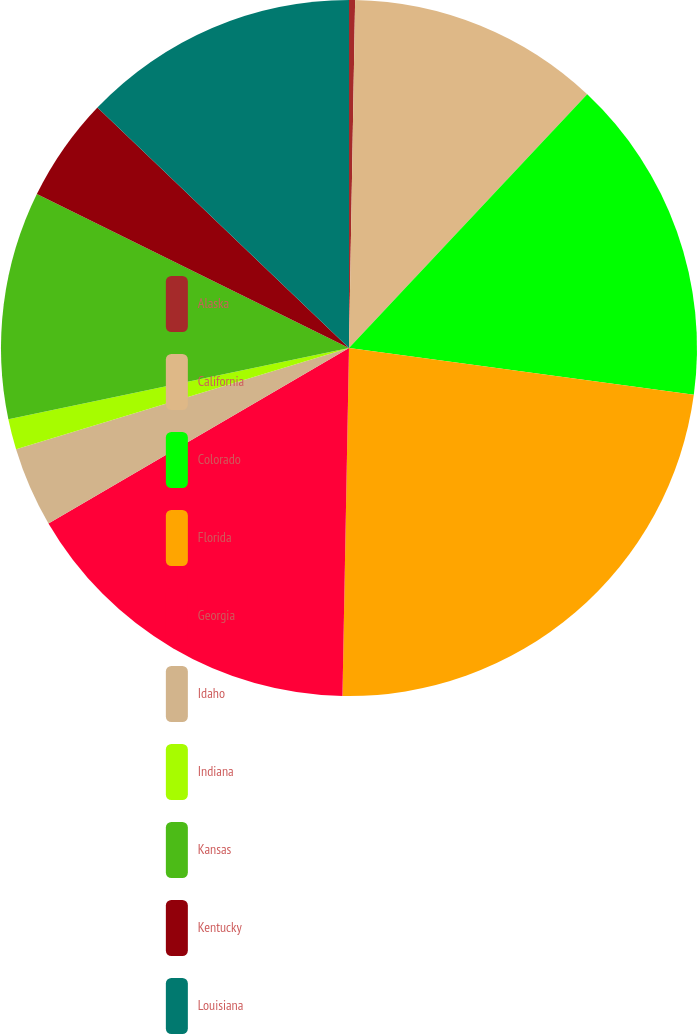Convert chart to OTSL. <chart><loc_0><loc_0><loc_500><loc_500><pie_chart><fcel>Alaska<fcel>California<fcel>Colorado<fcel>Florida<fcel>Georgia<fcel>Idaho<fcel>Indiana<fcel>Kansas<fcel>Kentucky<fcel>Louisiana<nl><fcel>0.28%<fcel>11.72%<fcel>15.15%<fcel>23.15%<fcel>16.29%<fcel>3.71%<fcel>1.42%<fcel>10.57%<fcel>4.85%<fcel>12.86%<nl></chart> 